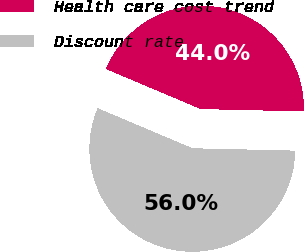Convert chart to OTSL. <chart><loc_0><loc_0><loc_500><loc_500><pie_chart><fcel>Health care cost trend<fcel>Discount rate<nl><fcel>44.0%<fcel>56.0%<nl></chart> 